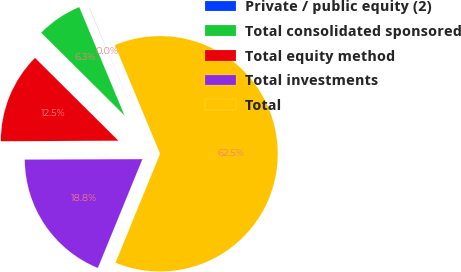<chart> <loc_0><loc_0><loc_500><loc_500><pie_chart><fcel>Private / public equity (2)<fcel>Total consolidated sponsored<fcel>Total equity method<fcel>Total investments<fcel>Total<nl><fcel>0.02%<fcel>6.26%<fcel>12.51%<fcel>18.75%<fcel>62.46%<nl></chart> 